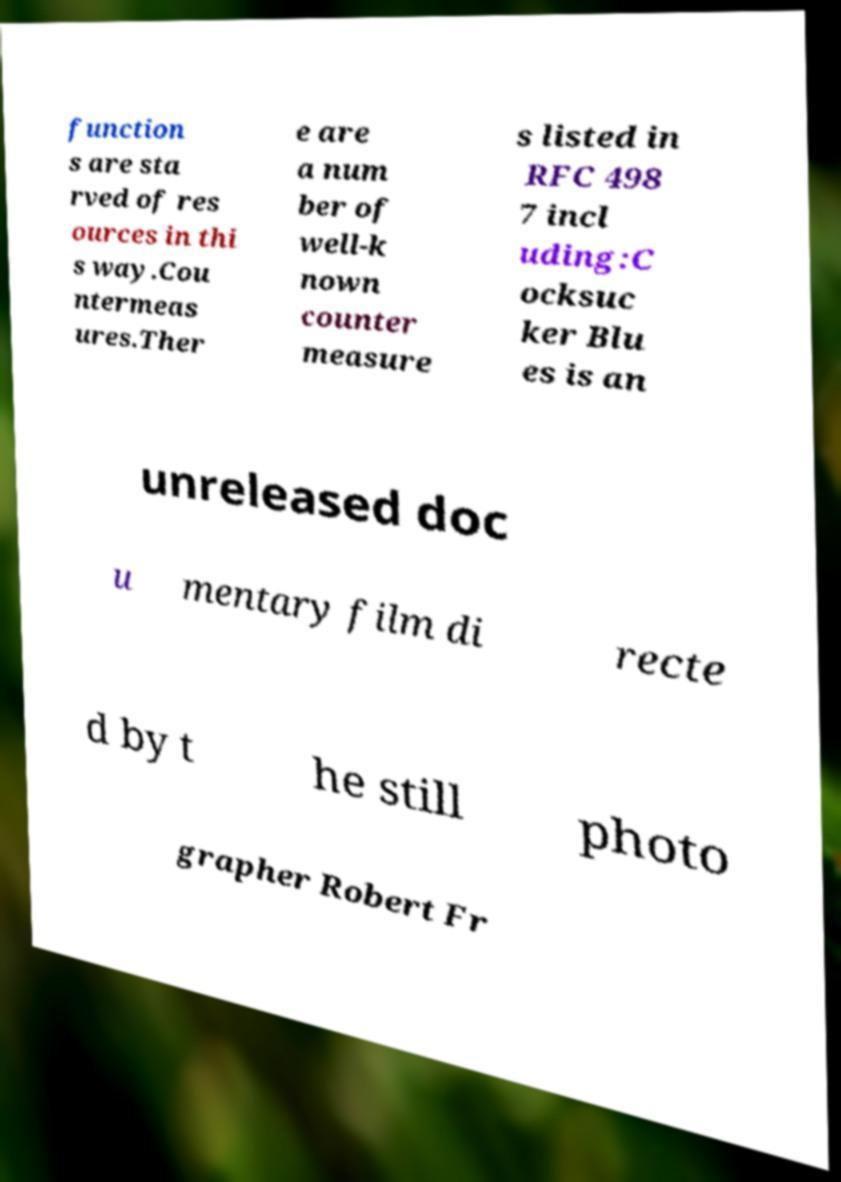Please identify and transcribe the text found in this image. function s are sta rved of res ources in thi s way.Cou ntermeas ures.Ther e are a num ber of well-k nown counter measure s listed in RFC 498 7 incl uding:C ocksuc ker Blu es is an unreleased doc u mentary film di recte d by t he still photo grapher Robert Fr 